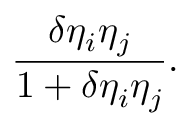<formula> <loc_0><loc_0><loc_500><loc_500>{ \frac { \delta \eta _ { i } \eta _ { j } } { 1 + \delta \eta _ { i } \eta _ { j } } } .</formula> 